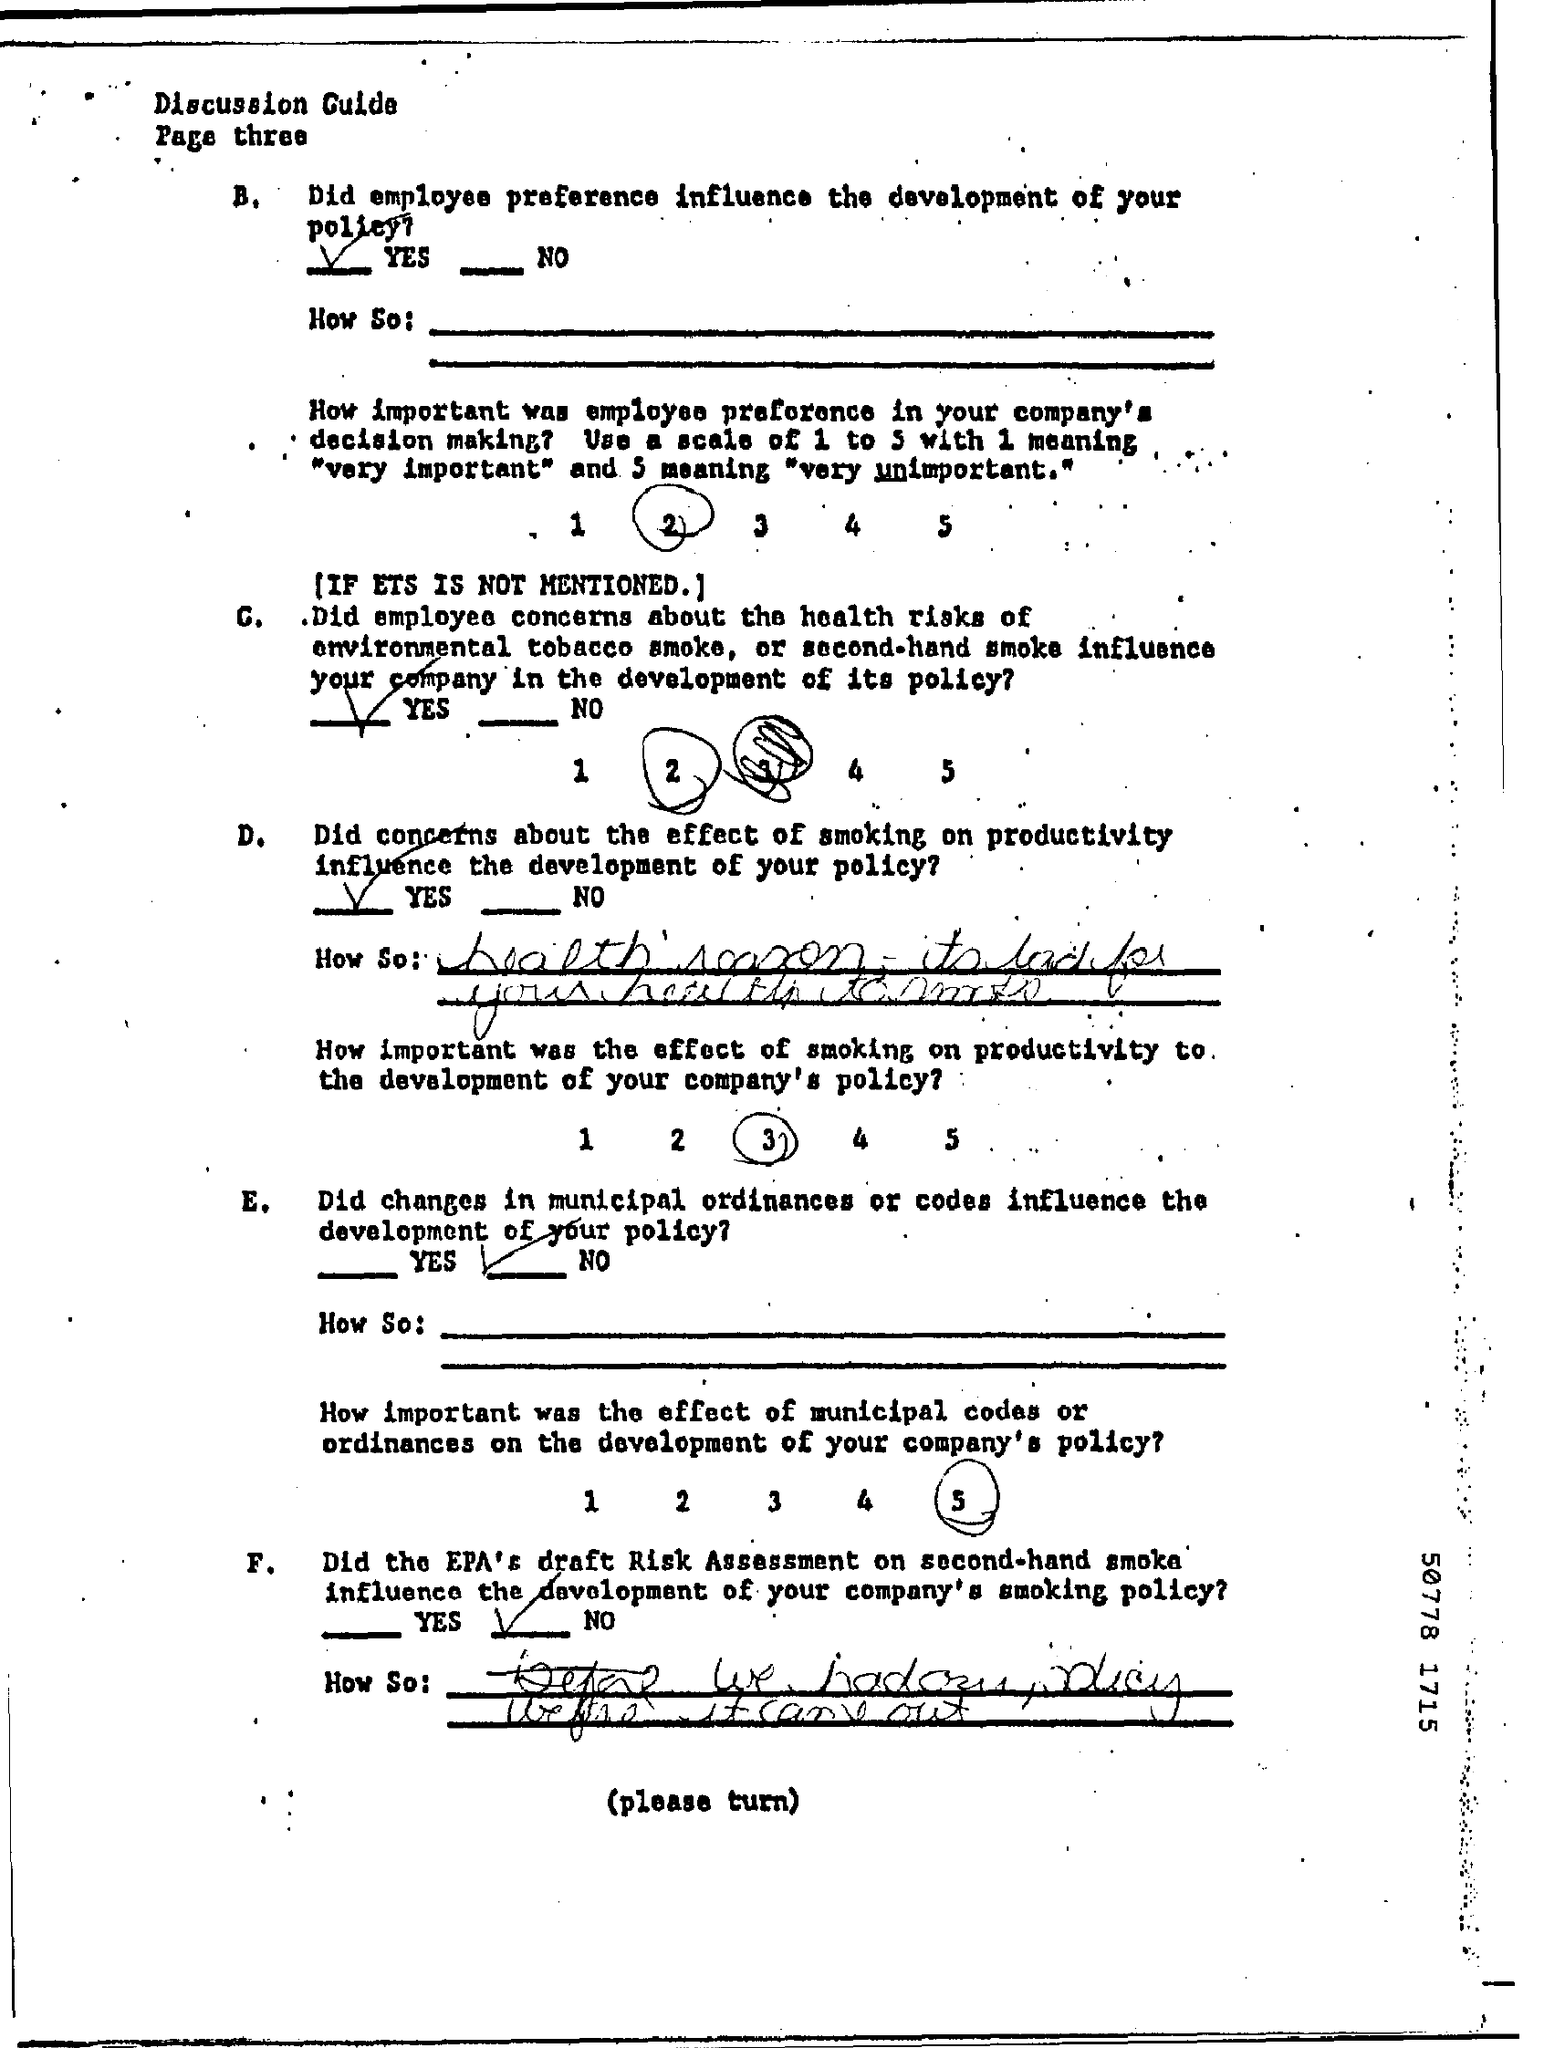Point out several critical features in this image. The title of the document is 'What is the Title of the document? discussion guide.' 